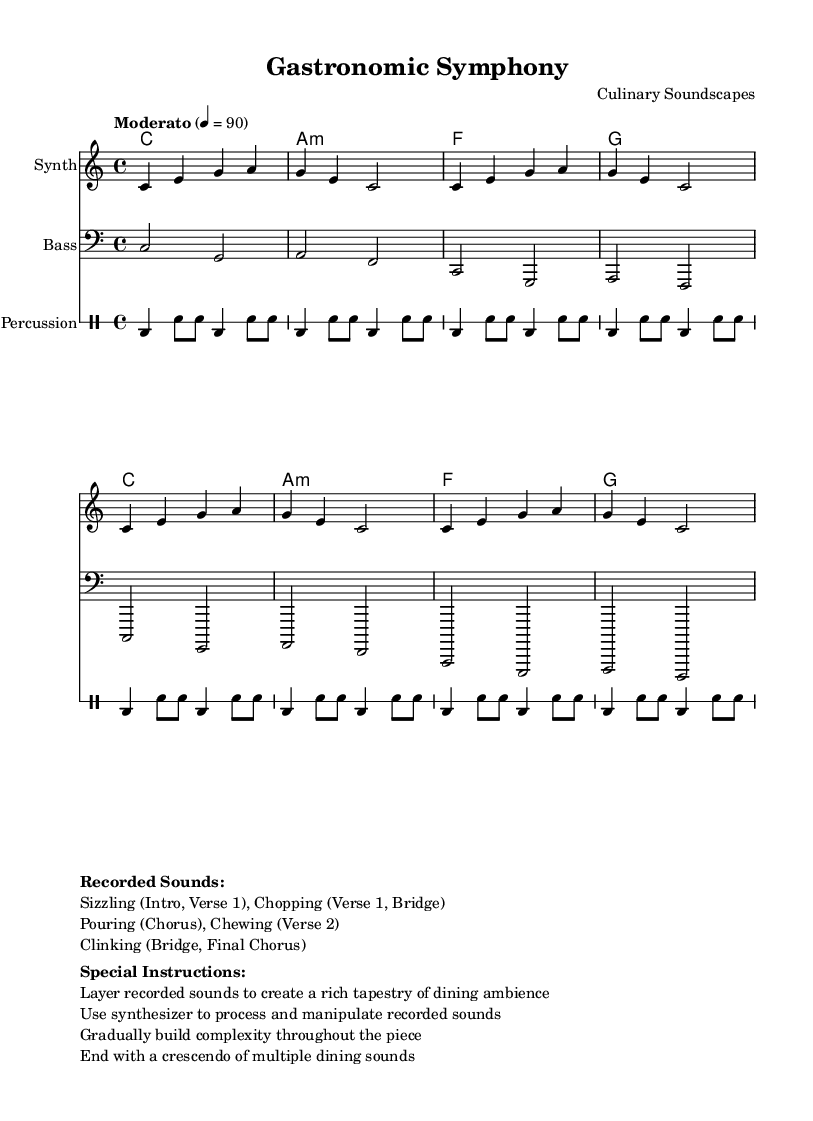What is the key signature of this music? The key signature indicated is C major, which is characterized by having no sharps or flats in the staff.
Answer: C major What is the time signature of this piece? The time signature displayed is 4/4, which means there are four beats in each measure and the quarter note gets one beat.
Answer: 4/4 What is the tempo marking for this piece? The tempo marking is given as "Moderato" with a metronome marking of 90, indicating a moderate speed for the music.
Answer: Moderato, 90 How many recorded sounds are listed? The recorded sounds mentioned include sizzling, chopping, pouring, chewing, and clinking, totaling five different sounds.
Answer: 5 In which sections do the recorded sounds occur? The recorded sounds appear in various sections as follows: sizzling in Intro and Verse 1, chopping in Verse 1 and Bridge, pouring in the Chorus, chewing in Verse 2, and clinking in the Bridge and Final Chorus.
Answer: Intro, Verse 1, Chorus, Verse 2, Bridge, Final Chorus What specific instructions are provided for layering recorded sounds? The instructions specify to layer recorded sounds to create a rich tapestry of dining ambience while using a synthesizer to process and manipulate them.
Answer: Layer recorded sounds How should the piece conclude according to the special instructions? The piece should end with a crescendo of multiple dining sounds, which creates a climactic finish that emphasizes the dining experience.
Answer: Crescendo of multiple dining sounds 